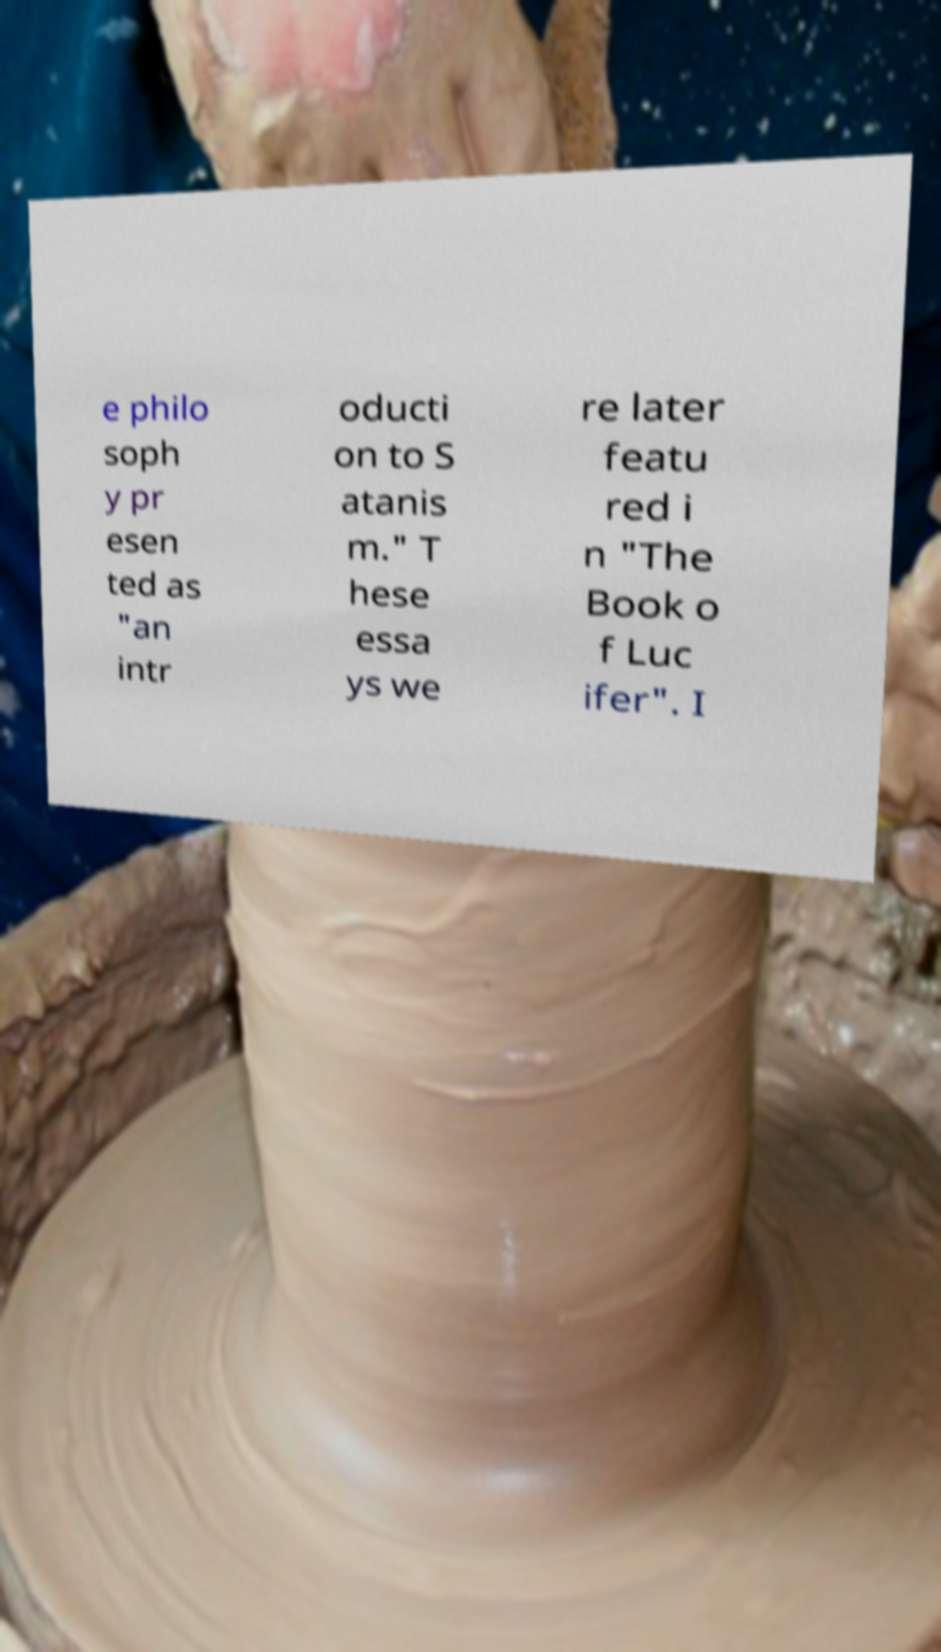Please read and relay the text visible in this image. What does it say? e philo soph y pr esen ted as "an intr oducti on to S atanis m." T hese essa ys we re later featu red i n "The Book o f Luc ifer". I 